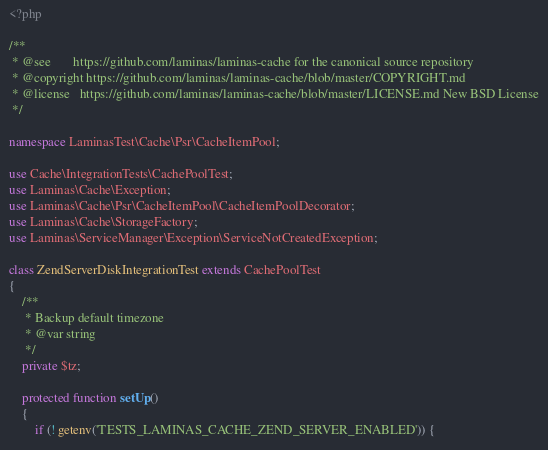Convert code to text. <code><loc_0><loc_0><loc_500><loc_500><_PHP_><?php

/**
 * @see       https://github.com/laminas/laminas-cache for the canonical source repository
 * @copyright https://github.com/laminas/laminas-cache/blob/master/COPYRIGHT.md
 * @license   https://github.com/laminas/laminas-cache/blob/master/LICENSE.md New BSD License
 */

namespace LaminasTest\Cache\Psr\CacheItemPool;

use Cache\IntegrationTests\CachePoolTest;
use Laminas\Cache\Exception;
use Laminas\Cache\Psr\CacheItemPool\CacheItemPoolDecorator;
use Laminas\Cache\StorageFactory;
use Laminas\ServiceManager\Exception\ServiceNotCreatedException;

class ZendServerDiskIntegrationTest extends CachePoolTest
{
    /**
     * Backup default timezone
     * @var string
     */
    private $tz;

    protected function setUp()
    {
        if (! getenv('TESTS_LAMINAS_CACHE_ZEND_SERVER_ENABLED')) {</code> 